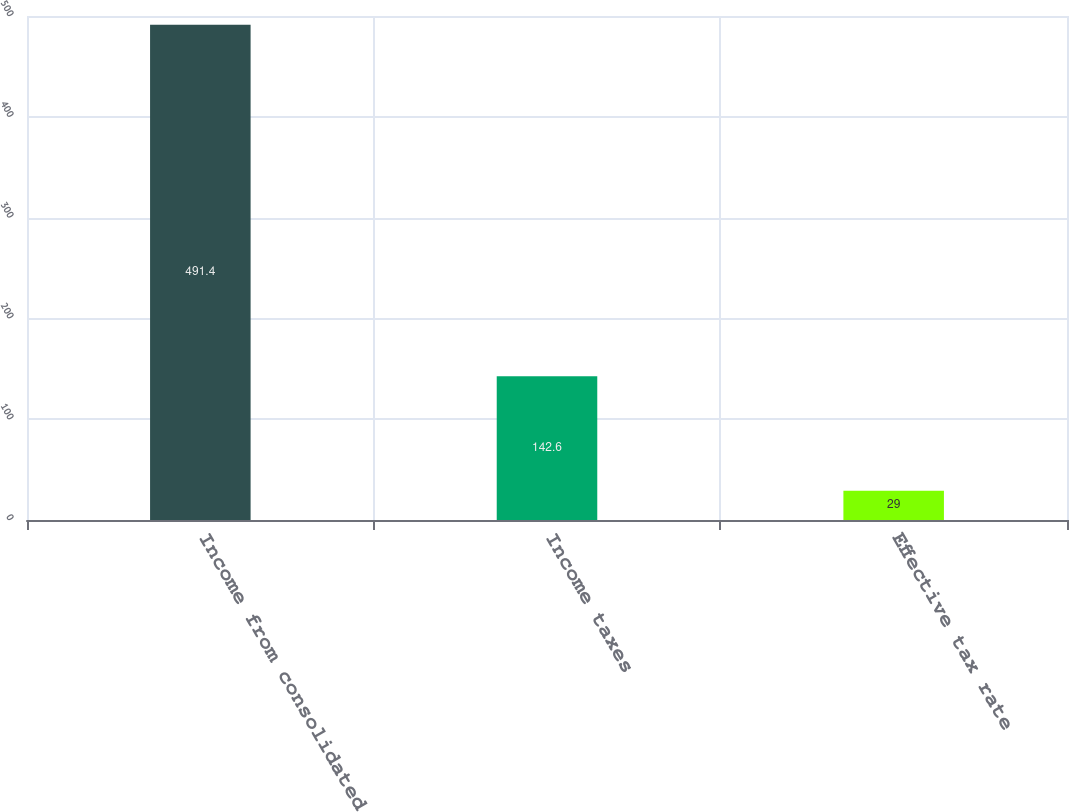Convert chart to OTSL. <chart><loc_0><loc_0><loc_500><loc_500><bar_chart><fcel>Income from consolidated<fcel>Income taxes<fcel>Effective tax rate<nl><fcel>491.4<fcel>142.6<fcel>29<nl></chart> 